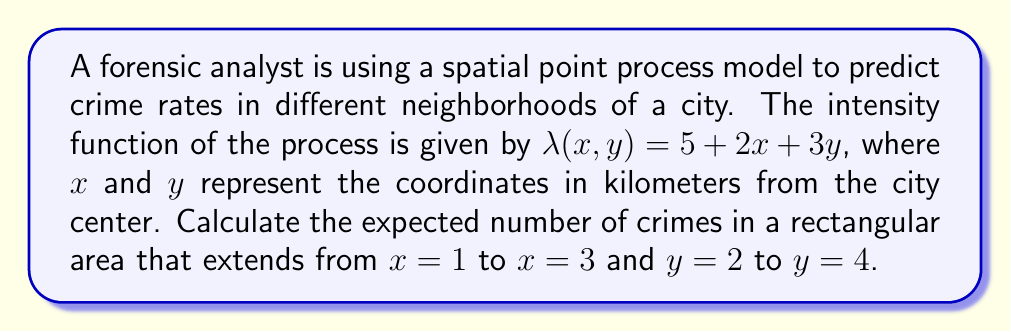Can you answer this question? To solve this problem, we need to follow these steps:

1) The expected number of events (crimes) in a region $A$ for a spatial point process with intensity function $\lambda(x, y)$ is given by the double integral:

   $$E[N(A)] = \int\int_A \lambda(x, y) dx dy$$

2) In this case, $\lambda(x, y) = 5 + 2x + 3y$, and the region $A$ is a rectangle with boundaries:
   $1 \leq x \leq 3$ and $2 \leq y \leq 4$

3) Let's set up the double integral:

   $$E[N(A)] = \int_2^4 \int_1^3 (5 + 2x + 3y) dx dy$$

4) First, integrate with respect to $x$:

   $$E[N(A)] = \int_2^4 \left[5x + x^2 + 3xy\right]_1^3 dy$$
   $$= \int_2^4 \left[(15 + 9 + 9y) - (5 + 1 + 3y)\right] dy$$
   $$= \int_2^4 (18 + 6y) dy$$

5) Now integrate with respect to $y$:

   $$E[N(A)] = \left[18y + 3y^2\right]_2^4$$
   $$= (72 + 48) - (36 + 12)$$
   $$= 120 - 48 = 72$$

Therefore, the expected number of crimes in the specified area is 72.
Answer: 72 crimes 